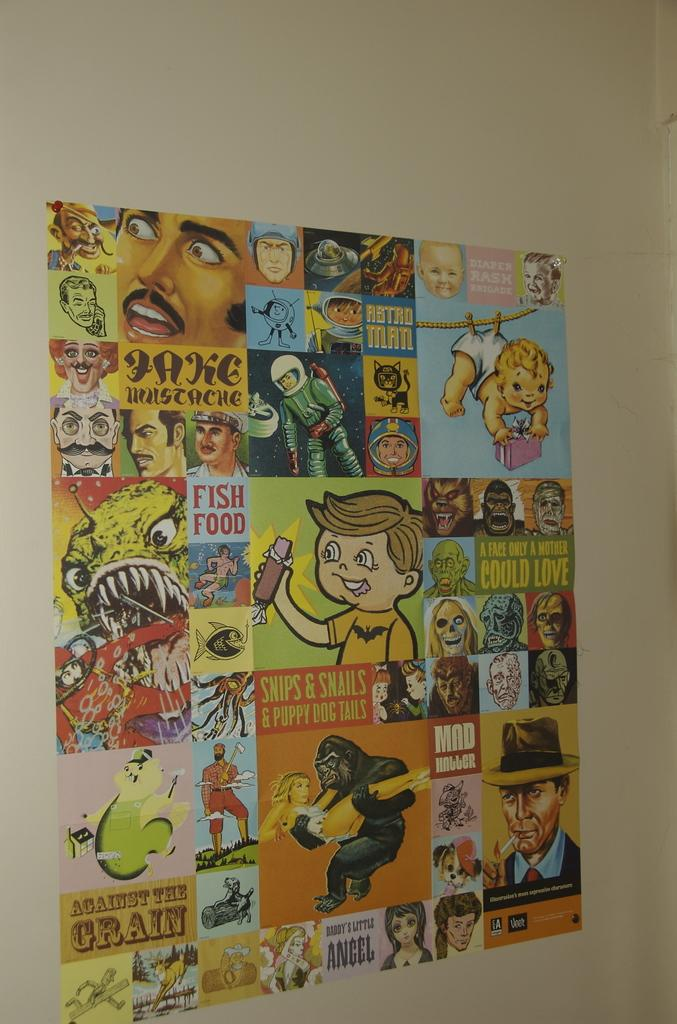What is on the wall in the image? There is a poster on the wall in the image. What type of content is featured on the poster? The poster contains animated pictures. What type of shoes are depicted in the animated pictures on the poster? There is no mention of shoes in the image or the provided facts, so we cannot determine if any shoes are depicted in the animated pictures. 